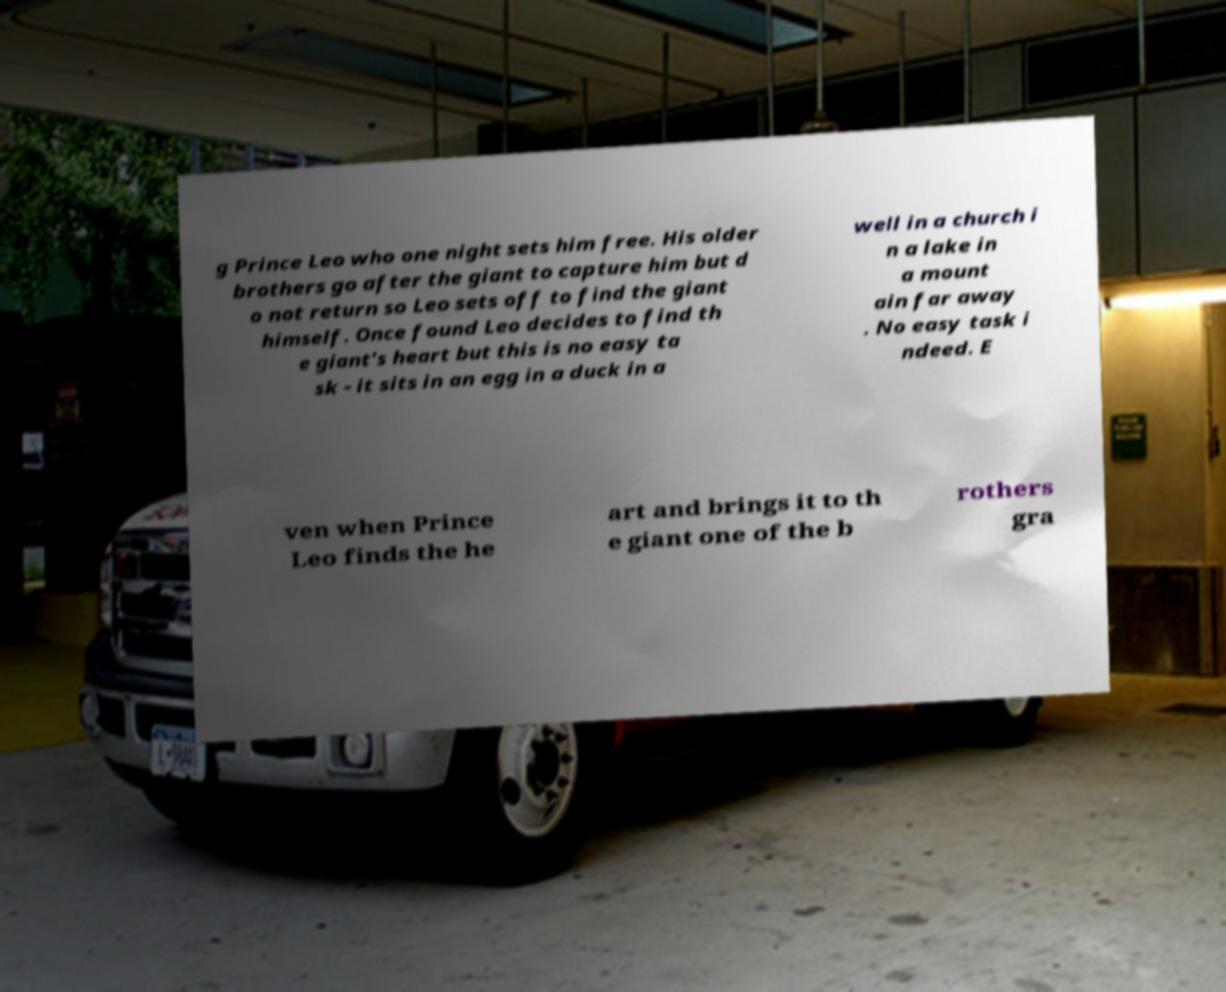What messages or text are displayed in this image? I need them in a readable, typed format. g Prince Leo who one night sets him free. His older brothers go after the giant to capture him but d o not return so Leo sets off to find the giant himself. Once found Leo decides to find th e giant's heart but this is no easy ta sk - it sits in an egg in a duck in a well in a church i n a lake in a mount ain far away . No easy task i ndeed. E ven when Prince Leo finds the he art and brings it to th e giant one of the b rothers gra 